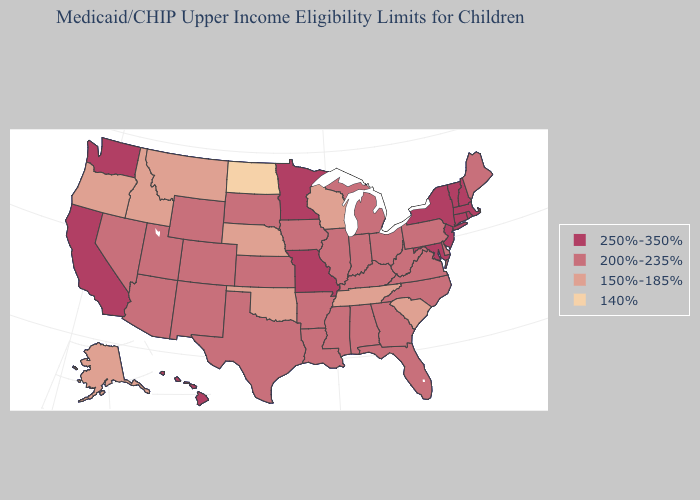Does the first symbol in the legend represent the smallest category?
Be succinct. No. Does the map have missing data?
Answer briefly. No. What is the highest value in states that border Oklahoma?
Give a very brief answer. 250%-350%. Name the states that have a value in the range 250%-350%?
Concise answer only. California, Connecticut, Hawaii, Maryland, Massachusetts, Minnesota, Missouri, New Hampshire, New Jersey, New York, Rhode Island, Vermont, Washington. Name the states that have a value in the range 250%-350%?
Give a very brief answer. California, Connecticut, Hawaii, Maryland, Massachusetts, Minnesota, Missouri, New Hampshire, New Jersey, New York, Rhode Island, Vermont, Washington. What is the highest value in states that border Ohio?
Concise answer only. 200%-235%. Name the states that have a value in the range 200%-235%?
Be succinct. Alabama, Arizona, Arkansas, Colorado, Delaware, Florida, Georgia, Illinois, Indiana, Iowa, Kansas, Kentucky, Louisiana, Maine, Michigan, Mississippi, Nevada, New Mexico, North Carolina, Ohio, Pennsylvania, South Dakota, Texas, Utah, Virginia, West Virginia, Wyoming. Name the states that have a value in the range 140%?
Concise answer only. North Dakota. Among the states that border Oregon , which have the highest value?
Concise answer only. California, Washington. What is the value of Rhode Island?
Give a very brief answer. 250%-350%. Does Idaho have the highest value in the USA?
Give a very brief answer. No. Does the first symbol in the legend represent the smallest category?
Give a very brief answer. No. What is the lowest value in the Northeast?
Answer briefly. 200%-235%. Name the states that have a value in the range 200%-235%?
Write a very short answer. Alabama, Arizona, Arkansas, Colorado, Delaware, Florida, Georgia, Illinois, Indiana, Iowa, Kansas, Kentucky, Louisiana, Maine, Michigan, Mississippi, Nevada, New Mexico, North Carolina, Ohio, Pennsylvania, South Dakota, Texas, Utah, Virginia, West Virginia, Wyoming. 